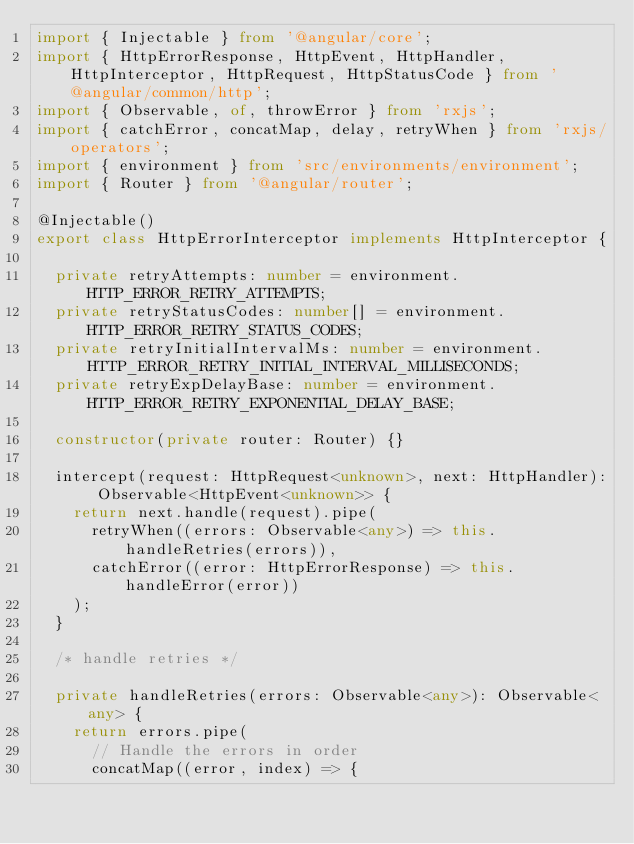Convert code to text. <code><loc_0><loc_0><loc_500><loc_500><_TypeScript_>import { Injectable } from '@angular/core';
import { HttpErrorResponse, HttpEvent, HttpHandler, HttpInterceptor, HttpRequest, HttpStatusCode } from '@angular/common/http';
import { Observable, of, throwError } from 'rxjs';
import { catchError, concatMap, delay, retryWhen } from 'rxjs/operators';
import { environment } from 'src/environments/environment';
import { Router } from '@angular/router';

@Injectable()
export class HttpErrorInterceptor implements HttpInterceptor {

  private retryAttempts: number = environment.HTTP_ERROR_RETRY_ATTEMPTS;
  private retryStatusCodes: number[] = environment.HTTP_ERROR_RETRY_STATUS_CODES;
  private retryInitialIntervalMs: number = environment.HTTP_ERROR_RETRY_INITIAL_INTERVAL_MILLISECONDS;
  private retryExpDelayBase: number = environment.HTTP_ERROR_RETRY_EXPONENTIAL_DELAY_BASE;

  constructor(private router: Router) {}

  intercept(request: HttpRequest<unknown>, next: HttpHandler): Observable<HttpEvent<unknown>> {
    return next.handle(request).pipe(
      retryWhen((errors: Observable<any>) => this.handleRetries(errors)),
      catchError((error: HttpErrorResponse) => this.handleError(error))
    );
  }

  /* handle retries */

  private handleRetries(errors: Observable<any>): Observable<any> {
    return errors.pipe(
      // Handle the errors in order
      concatMap((error, index) => {</code> 